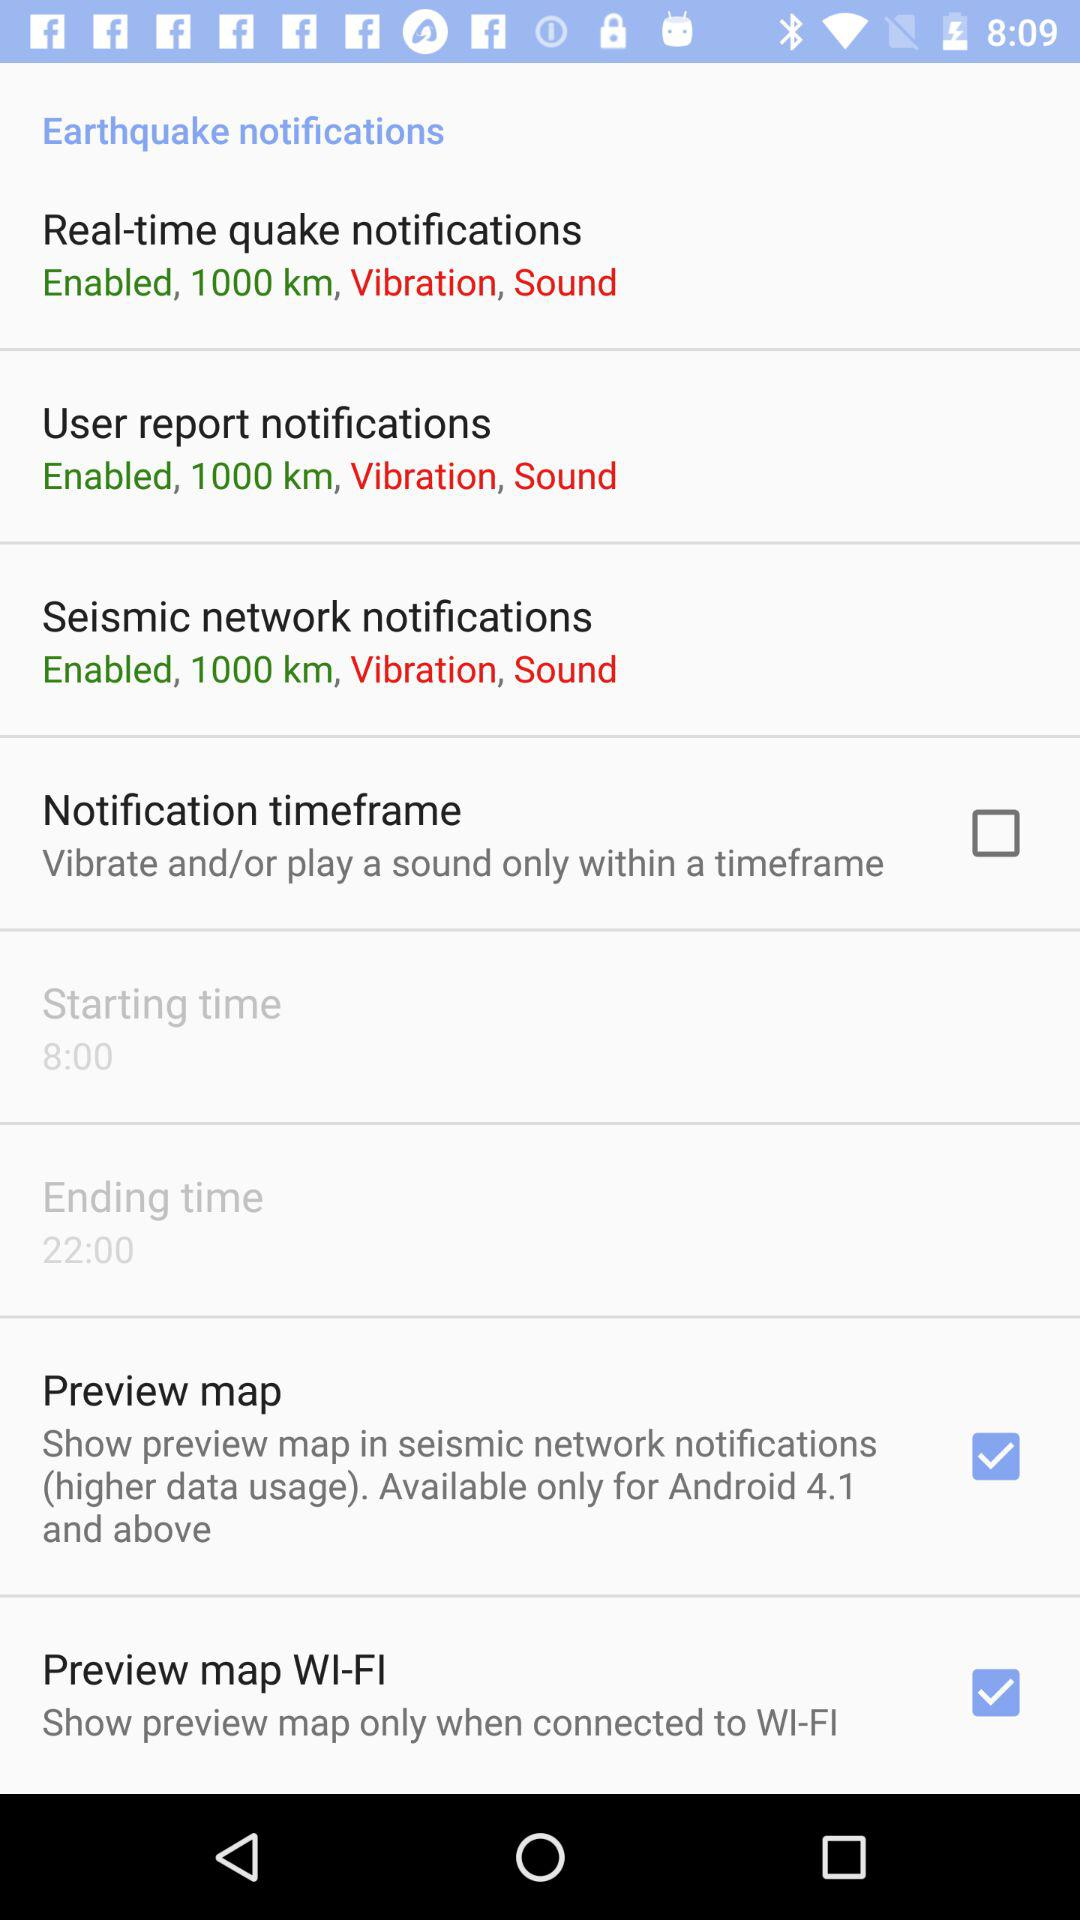Which option has been selected? The selected options are "Preview map" and "Preview map WI-FI". 